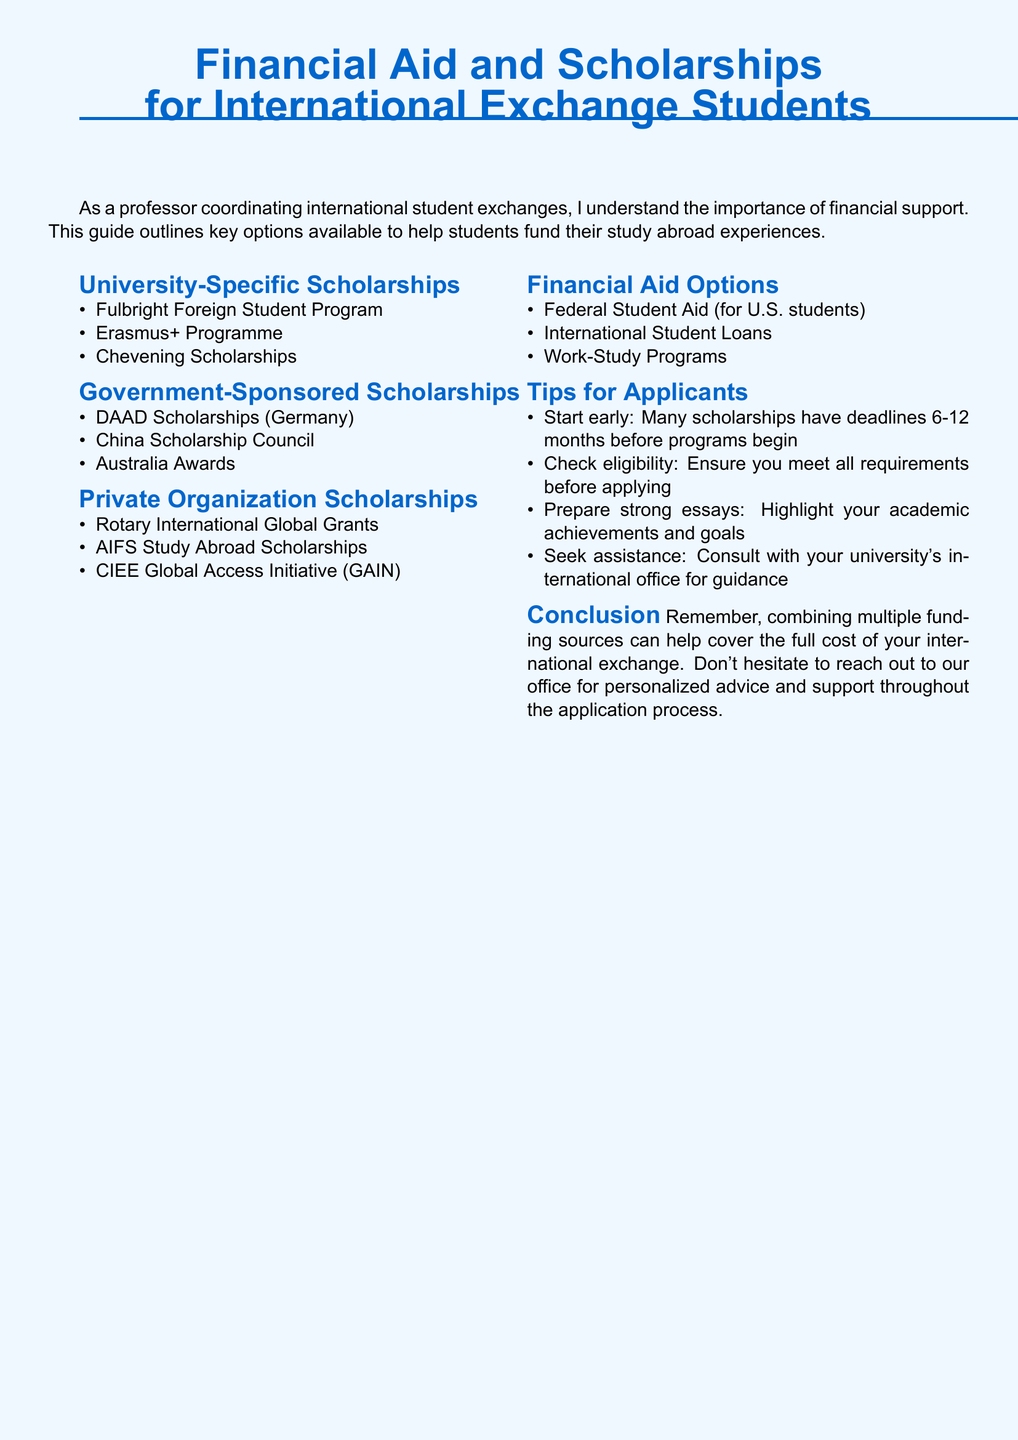What is the title of the document? The title is presented prominently at the top of the document to provide the main subject matter.
Answer: Financial Aid and Scholarships for International Exchange Students How many university-specific scholarships are listed? The document contains a section with a specific number of scholarships mentioned under university-specific options.
Answer: 3 What type of aid is available for U.S. students? This is outlined in the financial aid options section, specifically for students from the U.S.
Answer: Federal Student Aid Which organization provides the Chevening Scholarships? The document lists this scholarship under the university-specific scholarships, indicating its sponsor.
Answer: UK Government What is one tip suggested for scholarship applicants? Tips in the document offer practical advice to enhance chances of securing funding, which includes starting early.
Answer: Start early Are there any private organization scholarships mentioned? The document details a category for private organization scholarships, providing several examples.
Answer: Yes What is one type of government-sponsored scholarship mentioned? The document highlights different sources of scholarships and lists several options specific to this category.
Answer: DAAD Scholarships How many financial aid options are listed? The document clearly enumerates the options available for financial assistance in a designated section.
Answer: 3 Which program is mentioned under private organization scholarships? This refers to one of the specific scholarships listed in the private organization section of the document.
Answer: Rotary International Global Grants 